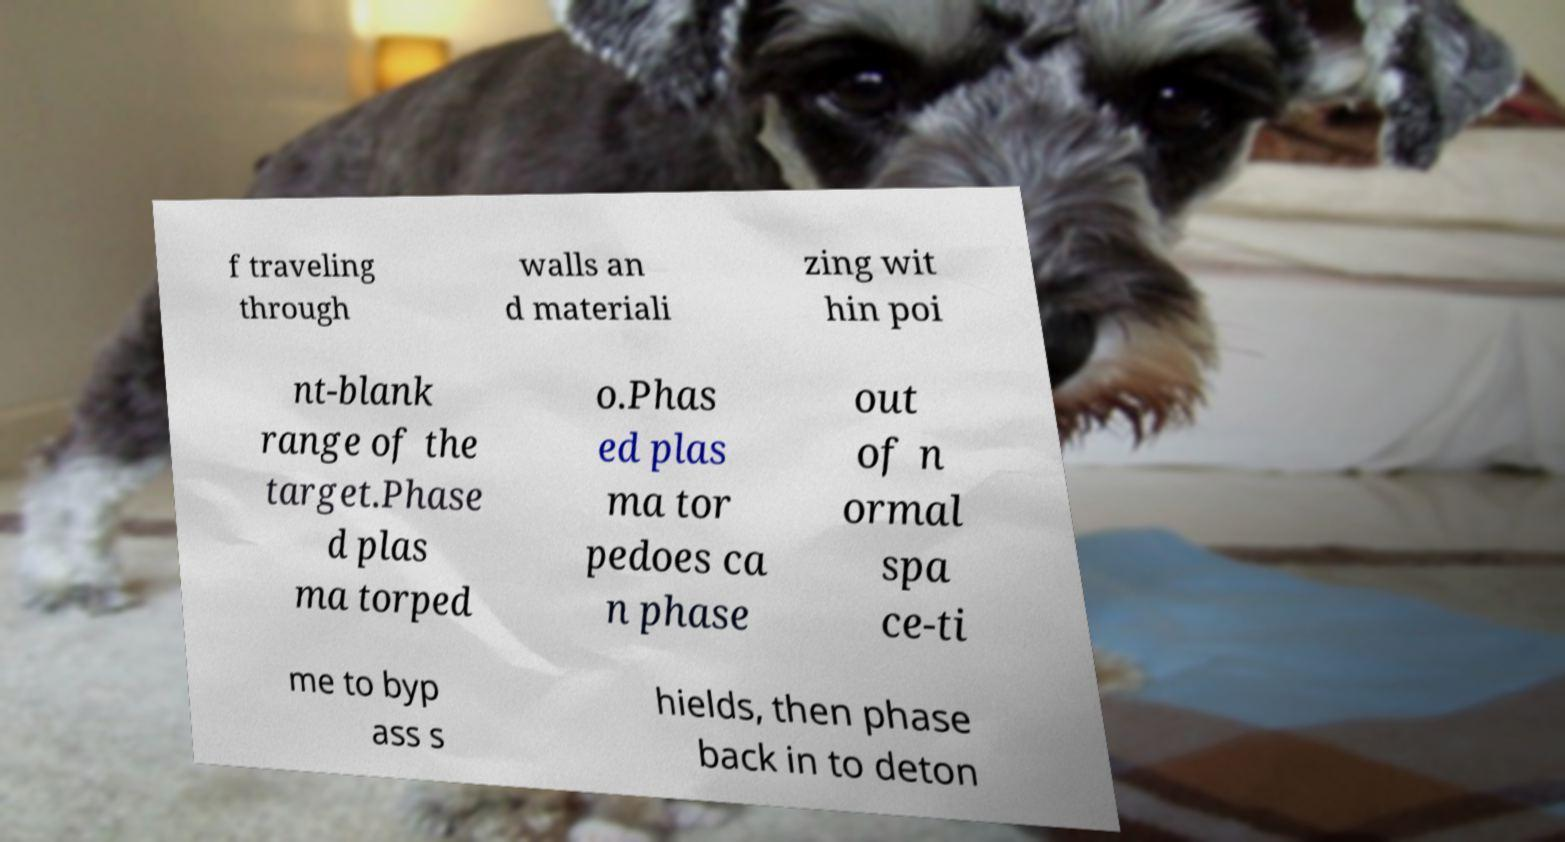Please identify and transcribe the text found in this image. f traveling through walls an d materiali zing wit hin poi nt-blank range of the target.Phase d plas ma torped o.Phas ed plas ma tor pedoes ca n phase out of n ormal spa ce-ti me to byp ass s hields, then phase back in to deton 